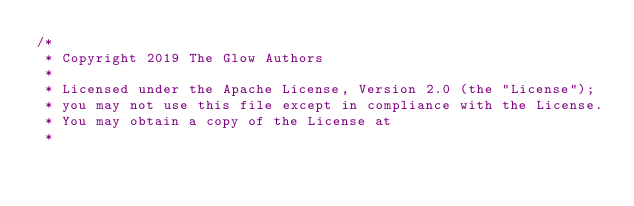Convert code to text. <code><loc_0><loc_0><loc_500><loc_500><_Scala_>/*
 * Copyright 2019 The Glow Authors
 *
 * Licensed under the Apache License, Version 2.0 (the "License");
 * you may not use this file except in compliance with the License.
 * You may obtain a copy of the License at
 *</code> 